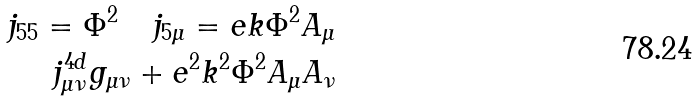Convert formula to latex. <formula><loc_0><loc_0><loc_500><loc_500>j _ { 5 5 } = \Phi ^ { 2 } \quad j _ { 5 \mu } = e k \Phi ^ { 2 } A _ { \mu } \\ j _ { \mu \nu } ^ { 4 d } g _ { \mu \nu } + e ^ { 2 } k ^ { 2 } \Phi ^ { 2 } A _ { \mu } A _ { \nu }</formula> 